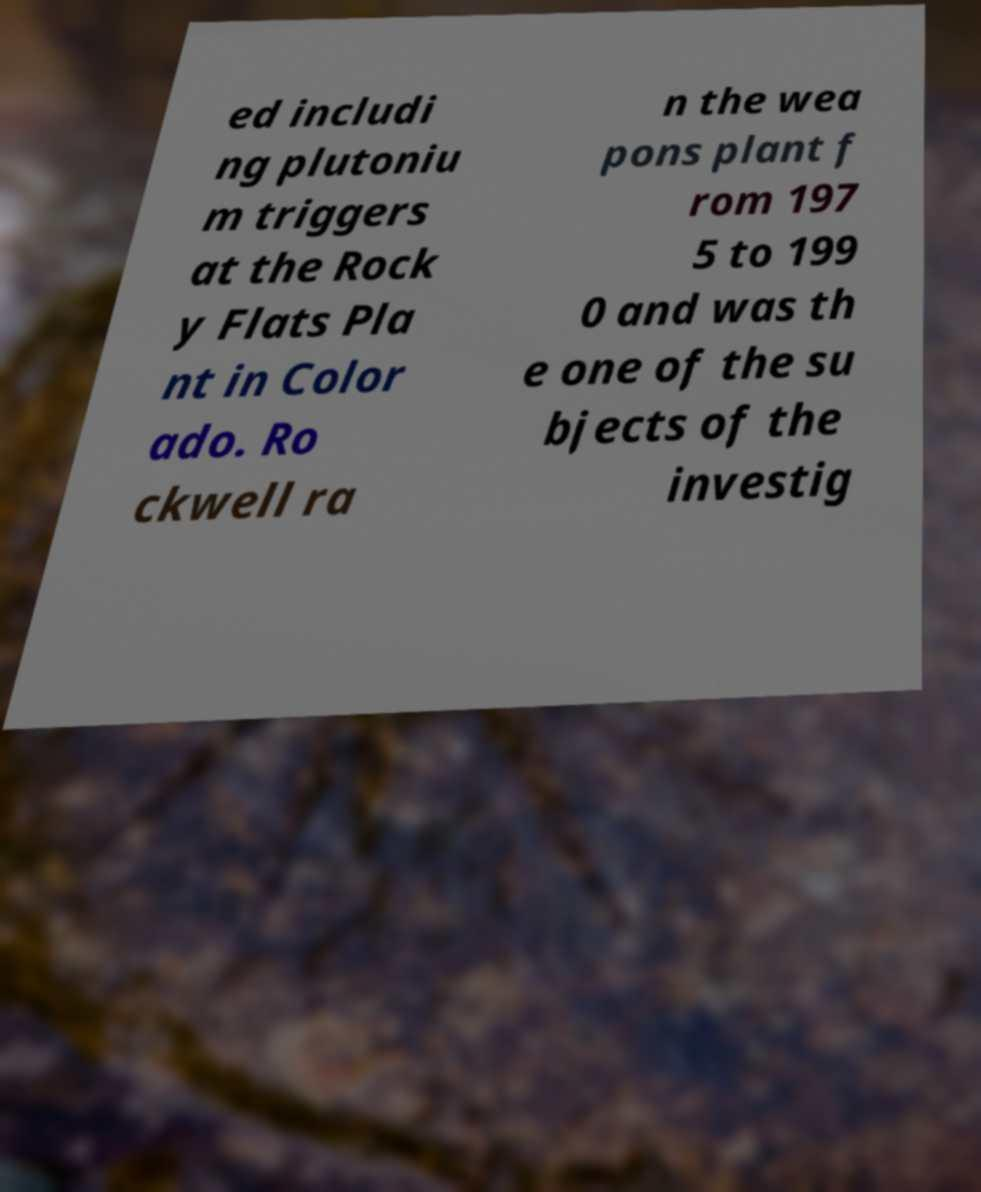There's text embedded in this image that I need extracted. Can you transcribe it verbatim? ed includi ng plutoniu m triggers at the Rock y Flats Pla nt in Color ado. Ro ckwell ra n the wea pons plant f rom 197 5 to 199 0 and was th e one of the su bjects of the investig 